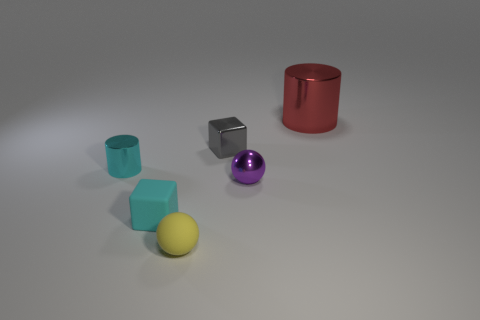Are there fewer tiny objects that are in front of the tiny cyan cylinder than tiny rubber cubes behind the large thing?
Keep it short and to the point. No. There is a cylinder that is to the left of the large red cylinder; what is its material?
Make the answer very short. Metal. There is a small metal thing that is on the right side of the tiny cyan metal object and behind the purple metallic ball; what is its color?
Offer a terse response. Gray. What number of other things are there of the same color as the tiny rubber block?
Provide a succinct answer. 1. There is a small rubber ball that is in front of the tiny gray object; what is its color?
Provide a short and direct response. Yellow. Are there any red things of the same size as the gray metallic object?
Ensure brevity in your answer.  No. There is a gray object that is the same size as the purple shiny thing; what material is it?
Your answer should be very brief. Metal. What number of things are either cyan matte things that are in front of the large cylinder or tiny objects that are on the right side of the tiny metallic cube?
Provide a succinct answer. 2. Are there any other matte things of the same shape as the large red object?
Give a very brief answer. No. What material is the thing that is the same color as the tiny cylinder?
Offer a very short reply. Rubber. 